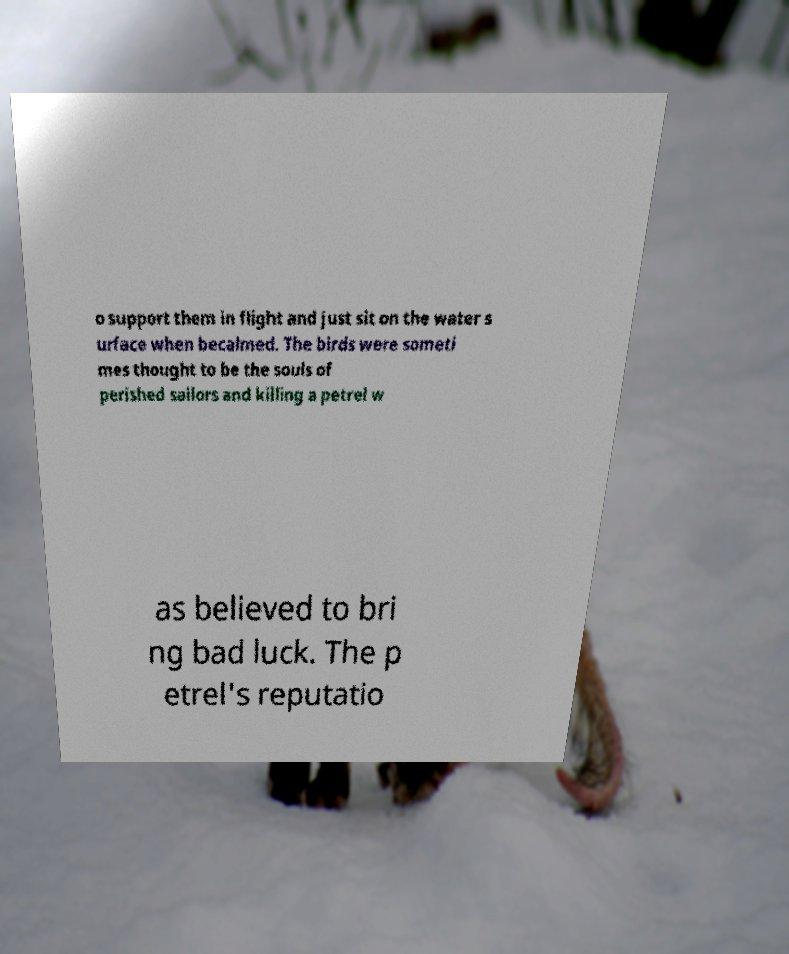Could you extract and type out the text from this image? o support them in flight and just sit on the water s urface when becalmed. The birds were someti mes thought to be the souls of perished sailors and killing a petrel w as believed to bri ng bad luck. The p etrel's reputatio 